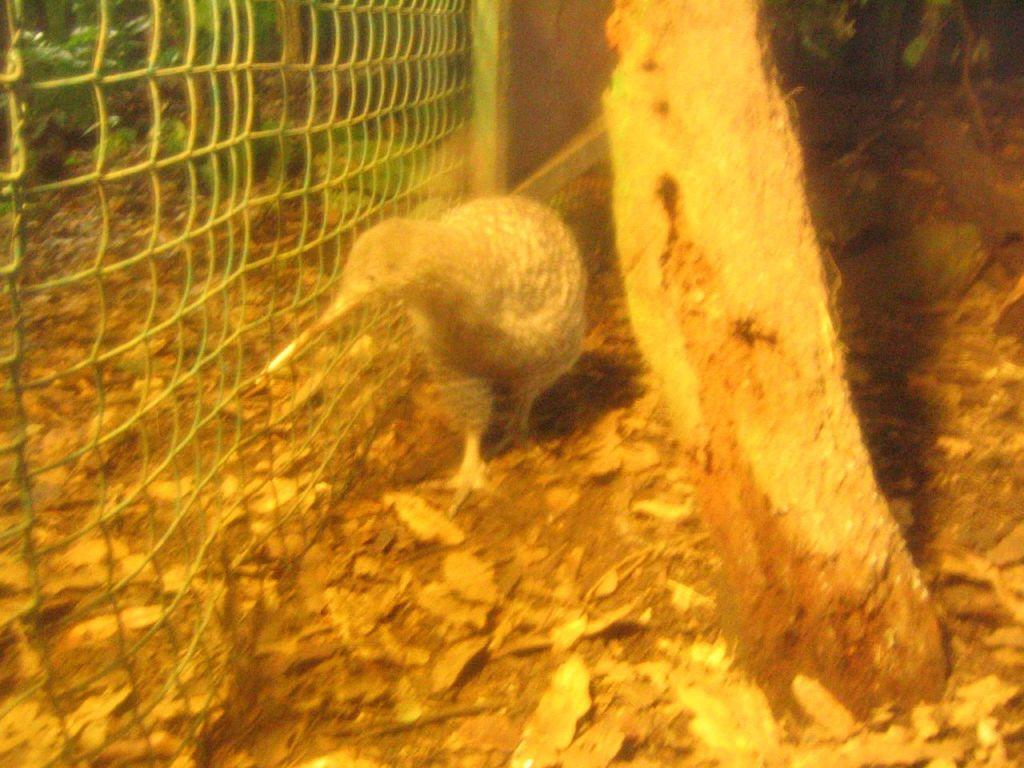What type of animal is in the image? There is a bird in the image. Where is the bird located in relation to other objects? The bird is beside a fence in the image. What other natural elements can be seen in the image? There are plants and leaves on the ground in the image. What part of a tree can be seen in the image? The trunk of a tree is visible in the image. How does the bird give a haircut to the clover in the image? There is no clover or haircut depicted in the image; it features a bird beside a fence with plants and leaves on the ground. 